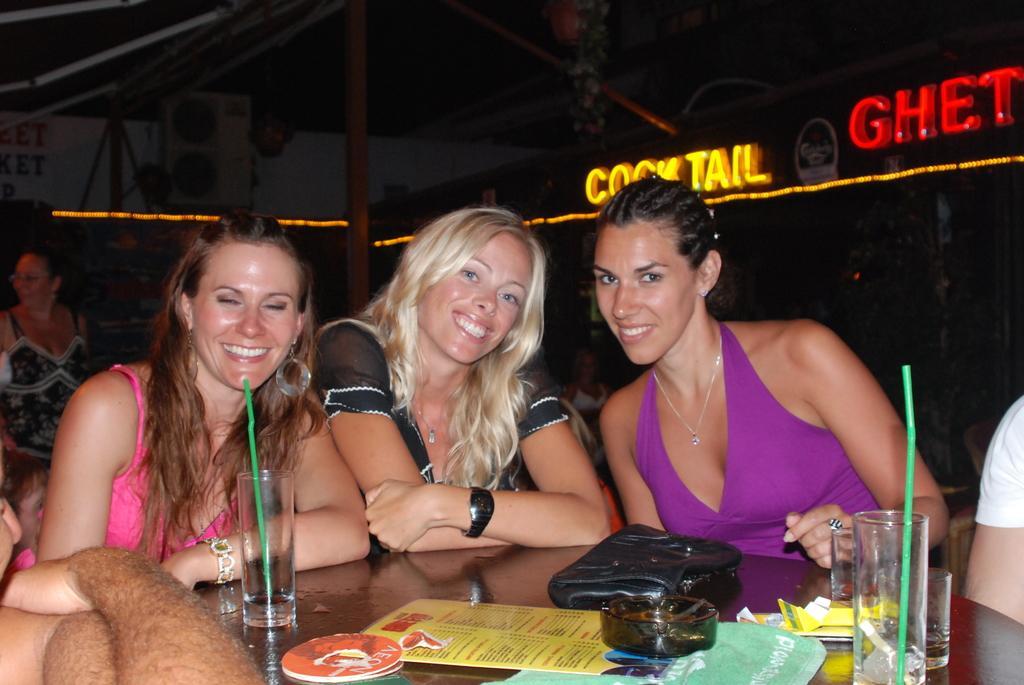In one or two sentences, can you explain what this image depicts? In the center of the image we can see three persons are standing and they are smiling. In front of them, there is a table. On the table, we can see glasses, straws, one bag, one ashtray, papers and a few other objects. In the background we can see the banners, lights, few people are sitting and a few other objects. 